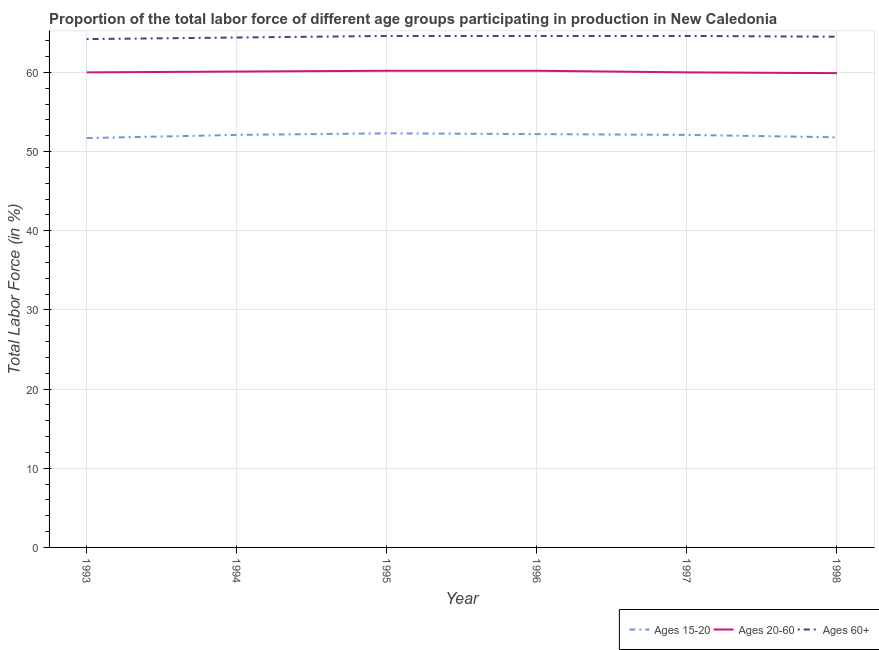How many different coloured lines are there?
Your answer should be compact. 3. Across all years, what is the maximum percentage of labor force within the age group 20-60?
Provide a short and direct response. 60.2. Across all years, what is the minimum percentage of labor force within the age group 15-20?
Ensure brevity in your answer.  51.7. In which year was the percentage of labor force within the age group 20-60 maximum?
Keep it short and to the point. 1995. In which year was the percentage of labor force within the age group 20-60 minimum?
Make the answer very short. 1998. What is the total percentage of labor force within the age group 15-20 in the graph?
Keep it short and to the point. 312.2. What is the difference between the percentage of labor force within the age group 15-20 in 1994 and that in 1996?
Give a very brief answer. -0.1. What is the difference between the percentage of labor force above age 60 in 1997 and the percentage of labor force within the age group 20-60 in 1995?
Your answer should be very brief. 4.4. What is the average percentage of labor force within the age group 20-60 per year?
Your answer should be very brief. 60.07. In the year 1997, what is the difference between the percentage of labor force within the age group 15-20 and percentage of labor force within the age group 20-60?
Your response must be concise. -7.9. In how many years, is the percentage of labor force within the age group 15-20 greater than 40 %?
Provide a succinct answer. 6. What is the ratio of the percentage of labor force within the age group 15-20 in 1993 to that in 1998?
Keep it short and to the point. 1. What is the difference between the highest and the second highest percentage of labor force within the age group 20-60?
Provide a short and direct response. 0. What is the difference between the highest and the lowest percentage of labor force within the age group 15-20?
Make the answer very short. 0.6. Is the percentage of labor force within the age group 20-60 strictly less than the percentage of labor force within the age group 15-20 over the years?
Offer a terse response. No. How many lines are there?
Make the answer very short. 3. How many years are there in the graph?
Make the answer very short. 6. Where does the legend appear in the graph?
Provide a succinct answer. Bottom right. How are the legend labels stacked?
Give a very brief answer. Horizontal. What is the title of the graph?
Offer a terse response. Proportion of the total labor force of different age groups participating in production in New Caledonia. Does "Ages 50+" appear as one of the legend labels in the graph?
Your answer should be very brief. No. What is the label or title of the Y-axis?
Ensure brevity in your answer.  Total Labor Force (in %). What is the Total Labor Force (in %) in Ages 15-20 in 1993?
Give a very brief answer. 51.7. What is the Total Labor Force (in %) in Ages 60+ in 1993?
Provide a short and direct response. 64.2. What is the Total Labor Force (in %) of Ages 15-20 in 1994?
Make the answer very short. 52.1. What is the Total Labor Force (in %) in Ages 20-60 in 1994?
Offer a very short reply. 60.1. What is the Total Labor Force (in %) of Ages 60+ in 1994?
Ensure brevity in your answer.  64.4. What is the Total Labor Force (in %) of Ages 15-20 in 1995?
Ensure brevity in your answer.  52.3. What is the Total Labor Force (in %) in Ages 20-60 in 1995?
Give a very brief answer. 60.2. What is the Total Labor Force (in %) in Ages 60+ in 1995?
Ensure brevity in your answer.  64.6. What is the Total Labor Force (in %) in Ages 15-20 in 1996?
Provide a succinct answer. 52.2. What is the Total Labor Force (in %) of Ages 20-60 in 1996?
Your response must be concise. 60.2. What is the Total Labor Force (in %) in Ages 60+ in 1996?
Offer a terse response. 64.6. What is the Total Labor Force (in %) in Ages 15-20 in 1997?
Your answer should be very brief. 52.1. What is the Total Labor Force (in %) of Ages 60+ in 1997?
Keep it short and to the point. 64.6. What is the Total Labor Force (in %) in Ages 15-20 in 1998?
Ensure brevity in your answer.  51.8. What is the Total Labor Force (in %) of Ages 20-60 in 1998?
Provide a short and direct response. 59.9. What is the Total Labor Force (in %) in Ages 60+ in 1998?
Make the answer very short. 64.5. Across all years, what is the maximum Total Labor Force (in %) in Ages 15-20?
Offer a very short reply. 52.3. Across all years, what is the maximum Total Labor Force (in %) in Ages 20-60?
Your answer should be compact. 60.2. Across all years, what is the maximum Total Labor Force (in %) in Ages 60+?
Give a very brief answer. 64.6. Across all years, what is the minimum Total Labor Force (in %) of Ages 15-20?
Offer a terse response. 51.7. Across all years, what is the minimum Total Labor Force (in %) in Ages 20-60?
Provide a short and direct response. 59.9. Across all years, what is the minimum Total Labor Force (in %) in Ages 60+?
Ensure brevity in your answer.  64.2. What is the total Total Labor Force (in %) in Ages 15-20 in the graph?
Give a very brief answer. 312.2. What is the total Total Labor Force (in %) in Ages 20-60 in the graph?
Provide a short and direct response. 360.4. What is the total Total Labor Force (in %) of Ages 60+ in the graph?
Ensure brevity in your answer.  386.9. What is the difference between the Total Labor Force (in %) in Ages 20-60 in 1993 and that in 1994?
Provide a short and direct response. -0.1. What is the difference between the Total Labor Force (in %) in Ages 20-60 in 1993 and that in 1995?
Offer a very short reply. -0.2. What is the difference between the Total Labor Force (in %) in Ages 60+ in 1993 and that in 1995?
Give a very brief answer. -0.4. What is the difference between the Total Labor Force (in %) of Ages 15-20 in 1993 and that in 1996?
Keep it short and to the point. -0.5. What is the difference between the Total Labor Force (in %) in Ages 15-20 in 1993 and that in 1997?
Offer a very short reply. -0.4. What is the difference between the Total Labor Force (in %) of Ages 60+ in 1993 and that in 1997?
Make the answer very short. -0.4. What is the difference between the Total Labor Force (in %) in Ages 15-20 in 1993 and that in 1998?
Make the answer very short. -0.1. What is the difference between the Total Labor Force (in %) in Ages 20-60 in 1993 and that in 1998?
Keep it short and to the point. 0.1. What is the difference between the Total Labor Force (in %) in Ages 20-60 in 1994 and that in 1995?
Provide a short and direct response. -0.1. What is the difference between the Total Labor Force (in %) of Ages 60+ in 1994 and that in 1995?
Your answer should be very brief. -0.2. What is the difference between the Total Labor Force (in %) in Ages 15-20 in 1994 and that in 1996?
Keep it short and to the point. -0.1. What is the difference between the Total Labor Force (in %) in Ages 20-60 in 1994 and that in 1996?
Give a very brief answer. -0.1. What is the difference between the Total Labor Force (in %) in Ages 60+ in 1994 and that in 1996?
Your answer should be very brief. -0.2. What is the difference between the Total Labor Force (in %) of Ages 15-20 in 1994 and that in 1997?
Provide a short and direct response. 0. What is the difference between the Total Labor Force (in %) in Ages 60+ in 1994 and that in 1997?
Provide a succinct answer. -0.2. What is the difference between the Total Labor Force (in %) in Ages 15-20 in 1994 and that in 1998?
Offer a terse response. 0.3. What is the difference between the Total Labor Force (in %) in Ages 60+ in 1994 and that in 1998?
Your answer should be very brief. -0.1. What is the difference between the Total Labor Force (in %) in Ages 60+ in 1995 and that in 1996?
Your response must be concise. 0. What is the difference between the Total Labor Force (in %) in Ages 20-60 in 1995 and that in 1997?
Offer a terse response. 0.2. What is the difference between the Total Labor Force (in %) of Ages 60+ in 1995 and that in 1997?
Offer a very short reply. 0. What is the difference between the Total Labor Force (in %) of Ages 60+ in 1996 and that in 1997?
Your response must be concise. 0. What is the difference between the Total Labor Force (in %) in Ages 15-20 in 1996 and that in 1998?
Give a very brief answer. 0.4. What is the difference between the Total Labor Force (in %) of Ages 20-60 in 1996 and that in 1998?
Offer a very short reply. 0.3. What is the difference between the Total Labor Force (in %) of Ages 60+ in 1996 and that in 1998?
Your answer should be compact. 0.1. What is the difference between the Total Labor Force (in %) of Ages 20-60 in 1997 and that in 1998?
Provide a succinct answer. 0.1. What is the difference between the Total Labor Force (in %) in Ages 60+ in 1997 and that in 1998?
Provide a succinct answer. 0.1. What is the difference between the Total Labor Force (in %) of Ages 15-20 in 1993 and the Total Labor Force (in %) of Ages 20-60 in 1994?
Your response must be concise. -8.4. What is the difference between the Total Labor Force (in %) of Ages 15-20 in 1993 and the Total Labor Force (in %) of Ages 20-60 in 1995?
Make the answer very short. -8.5. What is the difference between the Total Labor Force (in %) in Ages 15-20 in 1993 and the Total Labor Force (in %) in Ages 60+ in 1995?
Your answer should be very brief. -12.9. What is the difference between the Total Labor Force (in %) in Ages 20-60 in 1993 and the Total Labor Force (in %) in Ages 60+ in 1995?
Your response must be concise. -4.6. What is the difference between the Total Labor Force (in %) of Ages 15-20 in 1993 and the Total Labor Force (in %) of Ages 20-60 in 1997?
Your answer should be very brief. -8.3. What is the difference between the Total Labor Force (in %) of Ages 15-20 in 1993 and the Total Labor Force (in %) of Ages 60+ in 1997?
Ensure brevity in your answer.  -12.9. What is the difference between the Total Labor Force (in %) in Ages 20-60 in 1993 and the Total Labor Force (in %) in Ages 60+ in 1997?
Offer a very short reply. -4.6. What is the difference between the Total Labor Force (in %) in Ages 15-20 in 1993 and the Total Labor Force (in %) in Ages 20-60 in 1998?
Provide a short and direct response. -8.2. What is the difference between the Total Labor Force (in %) in Ages 15-20 in 1993 and the Total Labor Force (in %) in Ages 60+ in 1998?
Ensure brevity in your answer.  -12.8. What is the difference between the Total Labor Force (in %) in Ages 15-20 in 1994 and the Total Labor Force (in %) in Ages 20-60 in 1995?
Provide a succinct answer. -8.1. What is the difference between the Total Labor Force (in %) of Ages 15-20 in 1994 and the Total Labor Force (in %) of Ages 60+ in 1996?
Your response must be concise. -12.5. What is the difference between the Total Labor Force (in %) in Ages 15-20 in 1994 and the Total Labor Force (in %) in Ages 20-60 in 1997?
Your answer should be compact. -7.9. What is the difference between the Total Labor Force (in %) of Ages 20-60 in 1994 and the Total Labor Force (in %) of Ages 60+ in 1997?
Offer a terse response. -4.5. What is the difference between the Total Labor Force (in %) in Ages 15-20 in 1994 and the Total Labor Force (in %) in Ages 60+ in 1998?
Ensure brevity in your answer.  -12.4. What is the difference between the Total Labor Force (in %) of Ages 15-20 in 1995 and the Total Labor Force (in %) of Ages 20-60 in 1996?
Keep it short and to the point. -7.9. What is the difference between the Total Labor Force (in %) of Ages 15-20 in 1995 and the Total Labor Force (in %) of Ages 20-60 in 1997?
Your response must be concise. -7.7. What is the difference between the Total Labor Force (in %) of Ages 20-60 in 1995 and the Total Labor Force (in %) of Ages 60+ in 1997?
Provide a succinct answer. -4.4. What is the difference between the Total Labor Force (in %) in Ages 15-20 in 1995 and the Total Labor Force (in %) in Ages 20-60 in 1998?
Make the answer very short. -7.6. What is the difference between the Total Labor Force (in %) in Ages 15-20 in 1996 and the Total Labor Force (in %) in Ages 20-60 in 1998?
Provide a short and direct response. -7.7. What is the difference between the Total Labor Force (in %) of Ages 15-20 in 1996 and the Total Labor Force (in %) of Ages 60+ in 1998?
Ensure brevity in your answer.  -12.3. What is the difference between the Total Labor Force (in %) of Ages 20-60 in 1996 and the Total Labor Force (in %) of Ages 60+ in 1998?
Provide a short and direct response. -4.3. What is the difference between the Total Labor Force (in %) in Ages 15-20 in 1997 and the Total Labor Force (in %) in Ages 20-60 in 1998?
Provide a short and direct response. -7.8. What is the average Total Labor Force (in %) in Ages 15-20 per year?
Give a very brief answer. 52.03. What is the average Total Labor Force (in %) of Ages 20-60 per year?
Give a very brief answer. 60.07. What is the average Total Labor Force (in %) in Ages 60+ per year?
Your answer should be very brief. 64.48. In the year 1993, what is the difference between the Total Labor Force (in %) in Ages 15-20 and Total Labor Force (in %) in Ages 20-60?
Give a very brief answer. -8.3. In the year 1993, what is the difference between the Total Labor Force (in %) of Ages 20-60 and Total Labor Force (in %) of Ages 60+?
Provide a short and direct response. -4.2. In the year 1994, what is the difference between the Total Labor Force (in %) of Ages 15-20 and Total Labor Force (in %) of Ages 20-60?
Your response must be concise. -8. In the year 1994, what is the difference between the Total Labor Force (in %) in Ages 15-20 and Total Labor Force (in %) in Ages 60+?
Make the answer very short. -12.3. In the year 1994, what is the difference between the Total Labor Force (in %) of Ages 20-60 and Total Labor Force (in %) of Ages 60+?
Provide a succinct answer. -4.3. In the year 1995, what is the difference between the Total Labor Force (in %) in Ages 20-60 and Total Labor Force (in %) in Ages 60+?
Your response must be concise. -4.4. In the year 1996, what is the difference between the Total Labor Force (in %) of Ages 15-20 and Total Labor Force (in %) of Ages 20-60?
Ensure brevity in your answer.  -8. In the year 1996, what is the difference between the Total Labor Force (in %) of Ages 15-20 and Total Labor Force (in %) of Ages 60+?
Offer a very short reply. -12.4. In the year 1997, what is the difference between the Total Labor Force (in %) of Ages 15-20 and Total Labor Force (in %) of Ages 20-60?
Offer a terse response. -7.9. In the year 1997, what is the difference between the Total Labor Force (in %) in Ages 20-60 and Total Labor Force (in %) in Ages 60+?
Make the answer very short. -4.6. In the year 1998, what is the difference between the Total Labor Force (in %) of Ages 15-20 and Total Labor Force (in %) of Ages 60+?
Provide a short and direct response. -12.7. What is the ratio of the Total Labor Force (in %) in Ages 20-60 in 1993 to that in 1994?
Provide a succinct answer. 1. What is the ratio of the Total Labor Force (in %) in Ages 15-20 in 1993 to that in 1995?
Your answer should be very brief. 0.99. What is the ratio of the Total Labor Force (in %) in Ages 20-60 in 1993 to that in 1995?
Give a very brief answer. 1. What is the ratio of the Total Labor Force (in %) of Ages 60+ in 1993 to that in 1995?
Ensure brevity in your answer.  0.99. What is the ratio of the Total Labor Force (in %) in Ages 15-20 in 1993 to that in 1996?
Your answer should be compact. 0.99. What is the ratio of the Total Labor Force (in %) of Ages 60+ in 1993 to that in 1996?
Your answer should be very brief. 0.99. What is the ratio of the Total Labor Force (in %) of Ages 20-60 in 1993 to that in 1998?
Offer a terse response. 1. What is the ratio of the Total Labor Force (in %) of Ages 20-60 in 1994 to that in 1995?
Provide a succinct answer. 1. What is the ratio of the Total Labor Force (in %) of Ages 60+ in 1994 to that in 1995?
Offer a terse response. 1. What is the ratio of the Total Labor Force (in %) of Ages 15-20 in 1994 to that in 1996?
Keep it short and to the point. 1. What is the ratio of the Total Labor Force (in %) in Ages 15-20 in 1995 to that in 1998?
Your response must be concise. 1.01. What is the ratio of the Total Labor Force (in %) in Ages 15-20 in 1996 to that in 1997?
Provide a succinct answer. 1. What is the ratio of the Total Labor Force (in %) in Ages 60+ in 1996 to that in 1997?
Provide a succinct answer. 1. What is the ratio of the Total Labor Force (in %) in Ages 15-20 in 1996 to that in 1998?
Offer a terse response. 1.01. What is the ratio of the Total Labor Force (in %) in Ages 20-60 in 1996 to that in 1998?
Your answer should be very brief. 1. What is the ratio of the Total Labor Force (in %) in Ages 60+ in 1996 to that in 1998?
Provide a succinct answer. 1. What is the difference between the highest and the second highest Total Labor Force (in %) in Ages 20-60?
Your answer should be compact. 0. What is the difference between the highest and the lowest Total Labor Force (in %) in Ages 60+?
Keep it short and to the point. 0.4. 